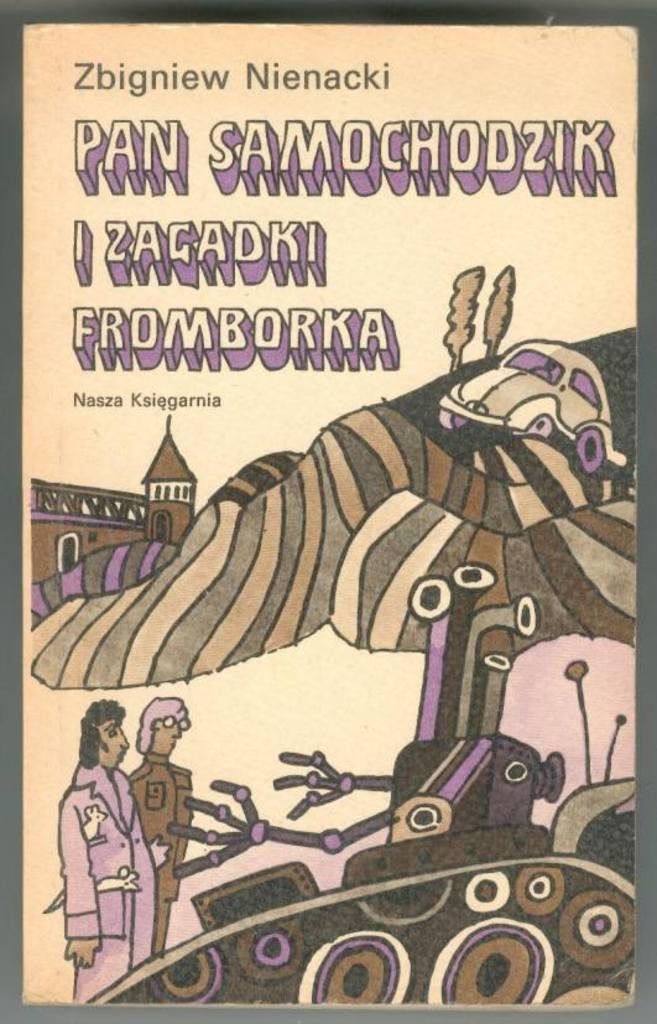What type of visual material is the image? The image is a poster. What elements are present on the poster? The poster has texts, an animated image, and a black color border. How many people are depicted in the image? There are two persons in the image. What other objects or characters can be seen in the image? There is a robot, a vehicle, a building, and trees in the image. What is the advertisement for in the image? There is no specific advertisement mentioned in the provided facts. --- Facts: 1. There is a person in the image. 12. The person is wearing a hat. 13. The person is holding a book. 14. The person is standing on a bridge. 15. The bridge is over a river. 16. The river has water flowing in it. 17. There are trees visible in the background. Absurd Topics: dinosaur, parrot, ocean Conversation: What is the main subject in the image? There is a person in the image. What is the person wearing? The person is wearing a hat. What is the person holding? The person is holding a book. Where is the person standing? The person is standing on a bridge. What is the bridge over? The bridge is over a river. What is the condition of the river? The river has water flowing in it. What can be seen in the background? There are trees visible in the background. Reasoning: Let's think step by step in order to produce the conversation. We start by identifying the main subject of the image, which is a person. Then, we describe the person's attire, specifically mentioning the hat. Next, we focus on the object the person is holding, which is a book. After that, we observe the person's location, which is on a bridge. We then describe the bridge's purpose, which is to cross over a river. Following that, we describe the river's condition, which is that it has water flowing in it. Finally, we mention the natural setting visible in the background, which are trees. Absurd Question/Answer: Can you see a dinosaur walking along the river in the image? No, there is no dinosaur visible in the image. --- Facts: 18. There is a person in the image. 19. The person is holding a ball. 120. The person is standing on a beach. 121. The beach has sand and water. 122. There are umbrellas visible in the background. Absurd Topics: elephant, giraffe, jungle Conversation: What is the main subject in the image? There is a person in the image. 